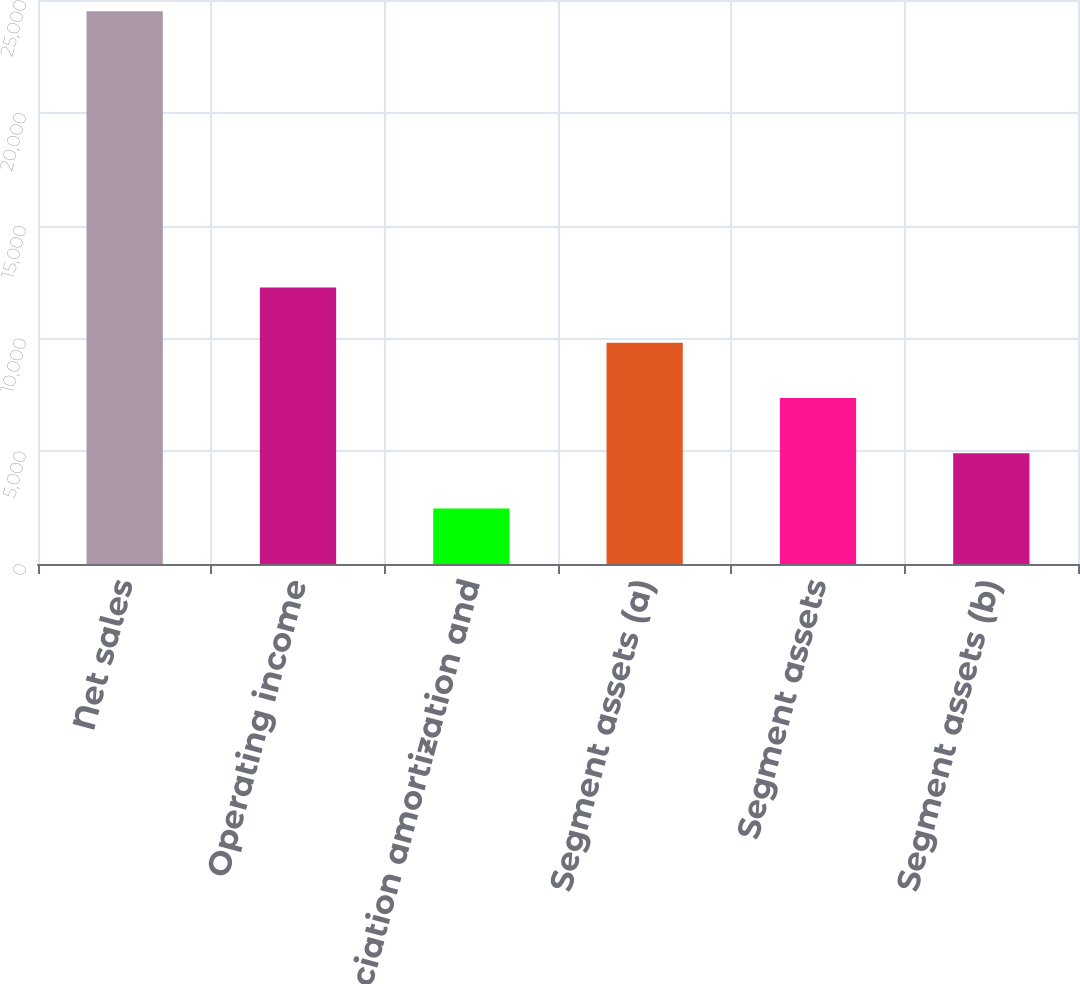Convert chart to OTSL. <chart><loc_0><loc_0><loc_500><loc_500><bar_chart><fcel>Net sales<fcel>Operating income<fcel>Depreciation amortization and<fcel>Segment assets (a)<fcel>Segment assets<fcel>Segment assets (b)<nl><fcel>24498<fcel>12255<fcel>2460.6<fcel>9806.4<fcel>7357.8<fcel>4909.2<nl></chart> 